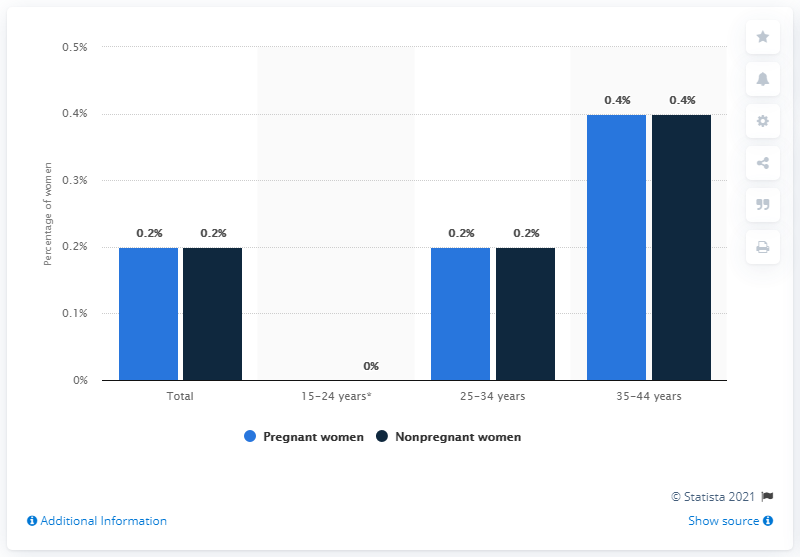Mention a couple of crucial points in this snapshot. According to the age range of women who died due to COVID-19, the majority of deceased individuals were between 35 and 44 years old. 